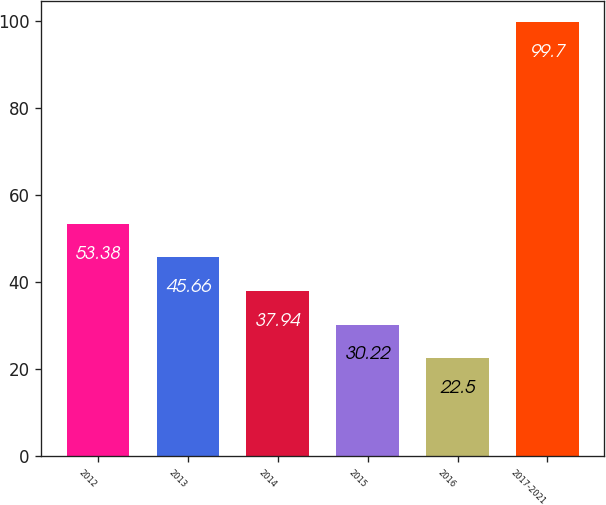<chart> <loc_0><loc_0><loc_500><loc_500><bar_chart><fcel>2012<fcel>2013<fcel>2014<fcel>2015<fcel>2016<fcel>2017-2021<nl><fcel>53.38<fcel>45.66<fcel>37.94<fcel>30.22<fcel>22.5<fcel>99.7<nl></chart> 